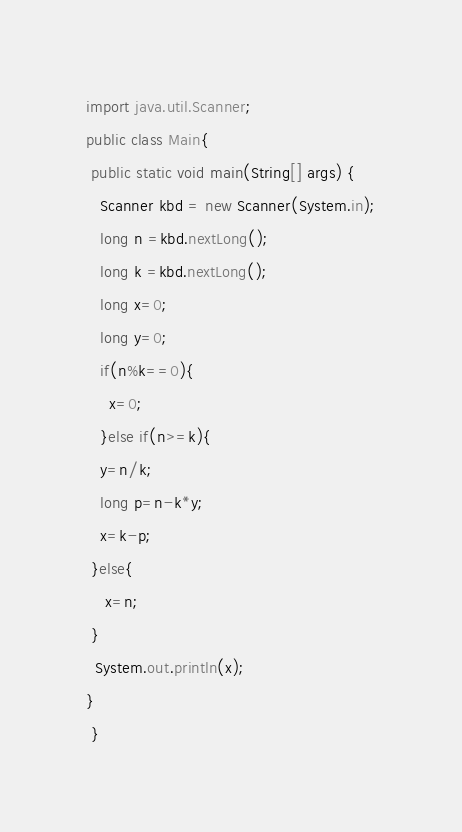<code> <loc_0><loc_0><loc_500><loc_500><_Java_>import java.util.Scanner;
public class Main{
 public static void main(String[] args) {
   Scanner kbd = new Scanner(System.in);
   long n =kbd.nextLong();
   long k =kbd.nextLong();
   long x=0;
   long y=0;
   if(n%k==0){
     x=0;
   }else if(n>=k){
   y=n/k;
   long p=n-k*y;
   x=k-p;
 }else{
    x=n;
 }
  System.out.println(x);
}
 }
</code> 